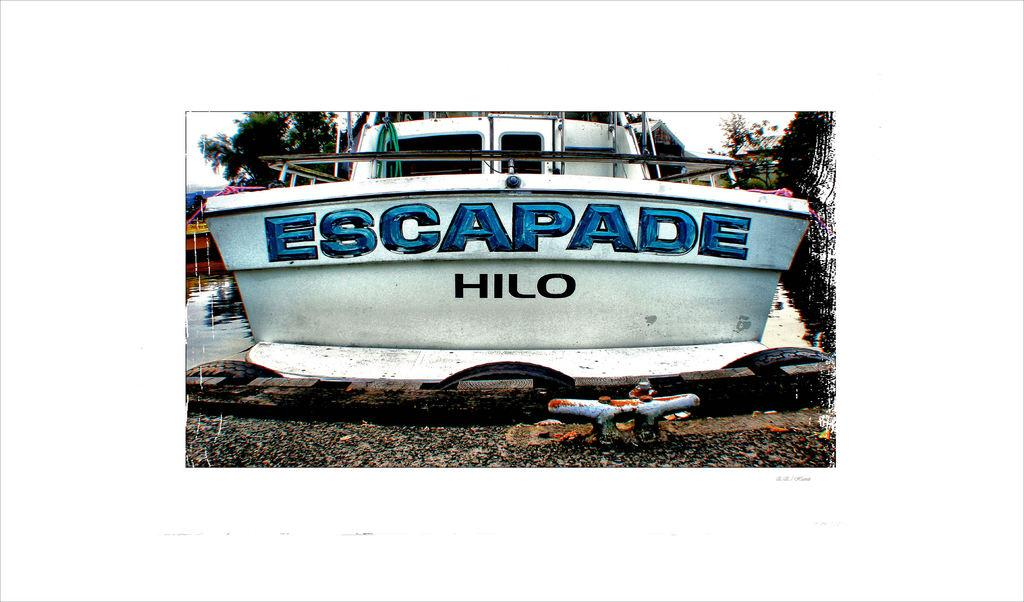<image>
Share a concise interpretation of the image provided. A ship that has the name "Escapade" is written on it 